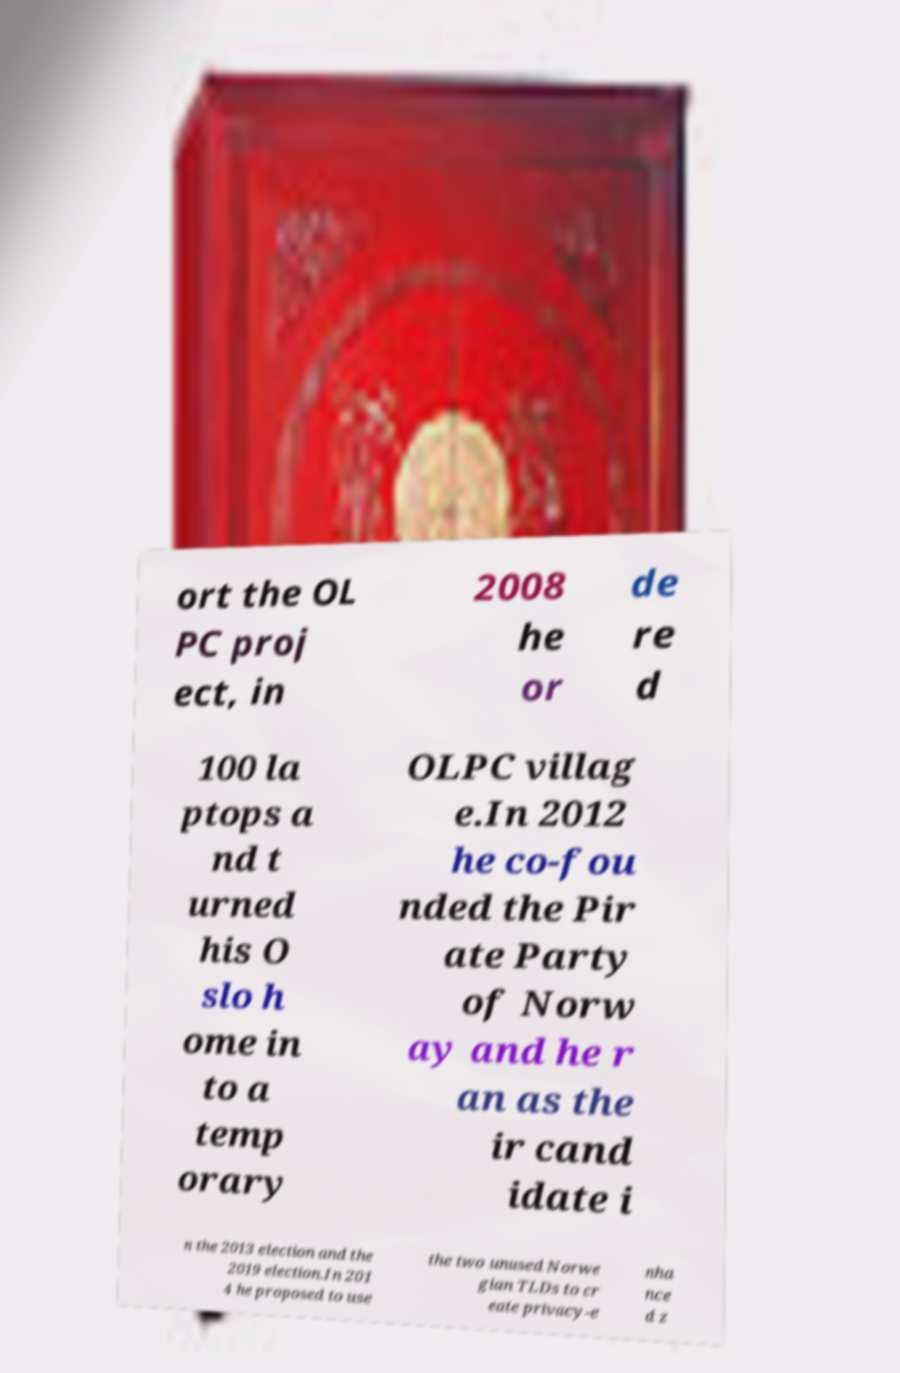Could you extract and type out the text from this image? ort the OL PC proj ect, in 2008 he or de re d 100 la ptops a nd t urned his O slo h ome in to a temp orary OLPC villag e.In 2012 he co-fou nded the Pir ate Party of Norw ay and he r an as the ir cand idate i n the 2013 election and the 2019 election.In 201 4 he proposed to use the two unused Norwe gian TLDs to cr eate privacy-e nha nce d z 